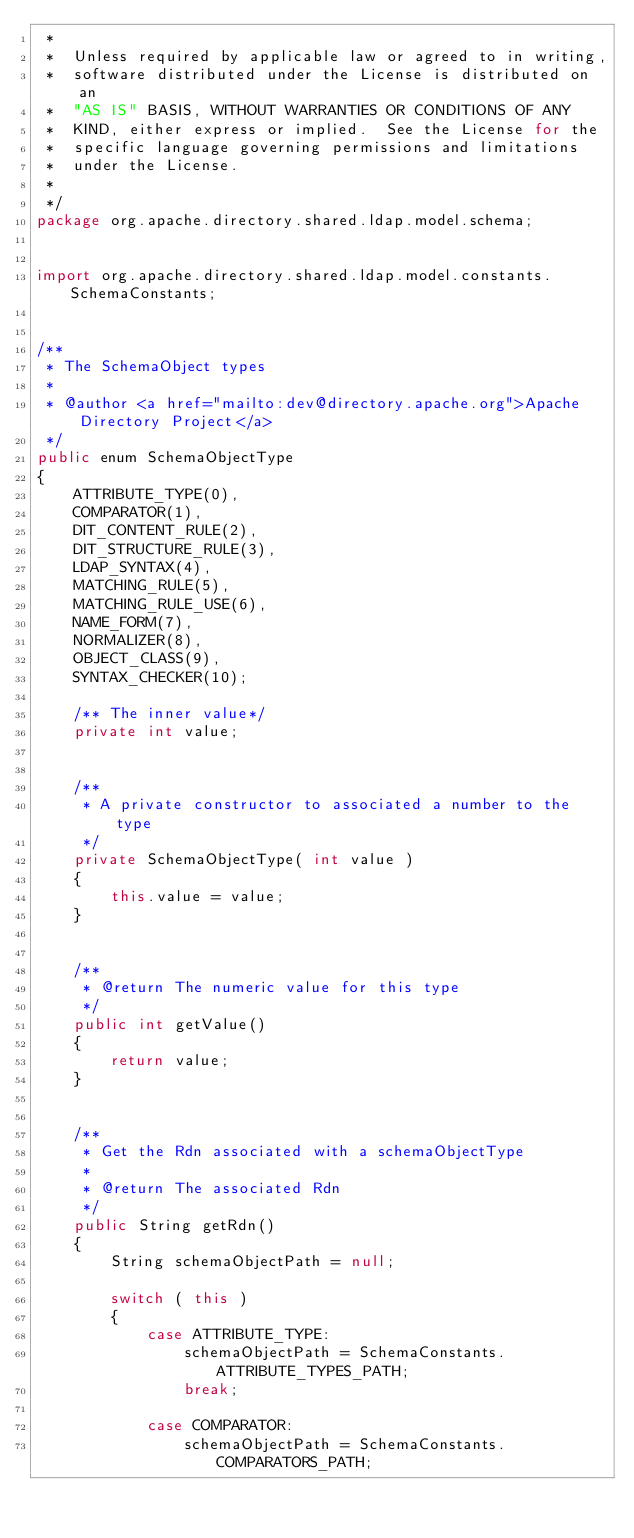Convert code to text. <code><loc_0><loc_0><loc_500><loc_500><_Java_> *  
 *  Unless required by applicable law or agreed to in writing,
 *  software distributed under the License is distributed on an
 *  "AS IS" BASIS, WITHOUT WARRANTIES OR CONDITIONS OF ANY
 *  KIND, either express or implied.  See the License for the
 *  specific language governing permissions and limitations
 *  under the License. 
 *  
 */
package org.apache.directory.shared.ldap.model.schema;


import org.apache.directory.shared.ldap.model.constants.SchemaConstants;


/**
 * The SchemaObject types
 *
 * @author <a href="mailto:dev@directory.apache.org">Apache Directory Project</a>
 */
public enum SchemaObjectType
{
    ATTRIBUTE_TYPE(0),
    COMPARATOR(1),
    DIT_CONTENT_RULE(2),
    DIT_STRUCTURE_RULE(3),
    LDAP_SYNTAX(4),
    MATCHING_RULE(5),
    MATCHING_RULE_USE(6),
    NAME_FORM(7),
    NORMALIZER(8),
    OBJECT_CLASS(9),
    SYNTAX_CHECKER(10);

    /** The inner value*/
    private int value;


    /**
     * A private constructor to associated a number to the type
     */
    private SchemaObjectType( int value )
    {
        this.value = value;
    }


    /**
     * @return The numeric value for this type
     */
    public int getValue()
    {
        return value;
    }


    /**
     * Get the Rdn associated with a schemaObjectType
     *
     * @return The associated Rdn
     */
    public String getRdn()
    {
        String schemaObjectPath = null;

        switch ( this )
        {
            case ATTRIBUTE_TYPE:
                schemaObjectPath = SchemaConstants.ATTRIBUTE_TYPES_PATH;
                break;

            case COMPARATOR:
                schemaObjectPath = SchemaConstants.COMPARATORS_PATH;</code> 